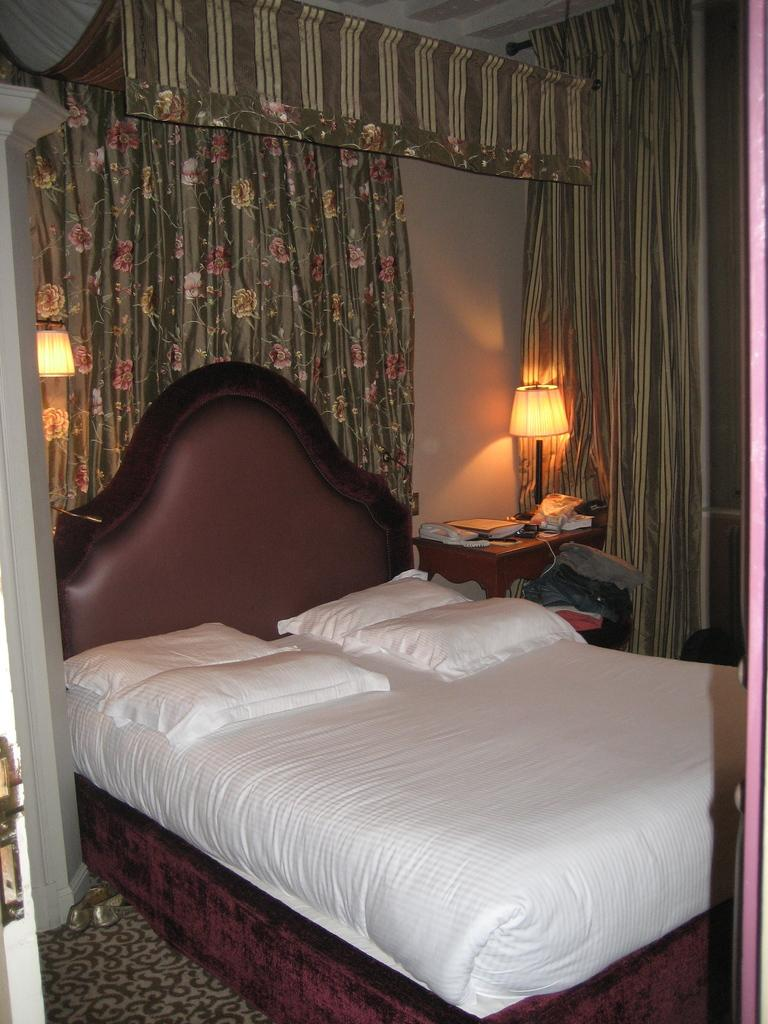What type of furniture is present in the image? There is a bed in the image. What can be found on the bed? There are pillows on the bed. What type of lighting is visible in the image? There is a light and a lamp in the image. What type of window treatment is present in the image? There are curtains in the image. What type of wall is visible in the image? There is a wall in the image. What type of objects can be found on the table? There are books and other objects on the table. How many cakes are on the bed in the image? There are no cakes present in the image. What type of ducks can be seen swimming in the lamp? There are no ducks present in the image, and the lamp is not a body of water. 